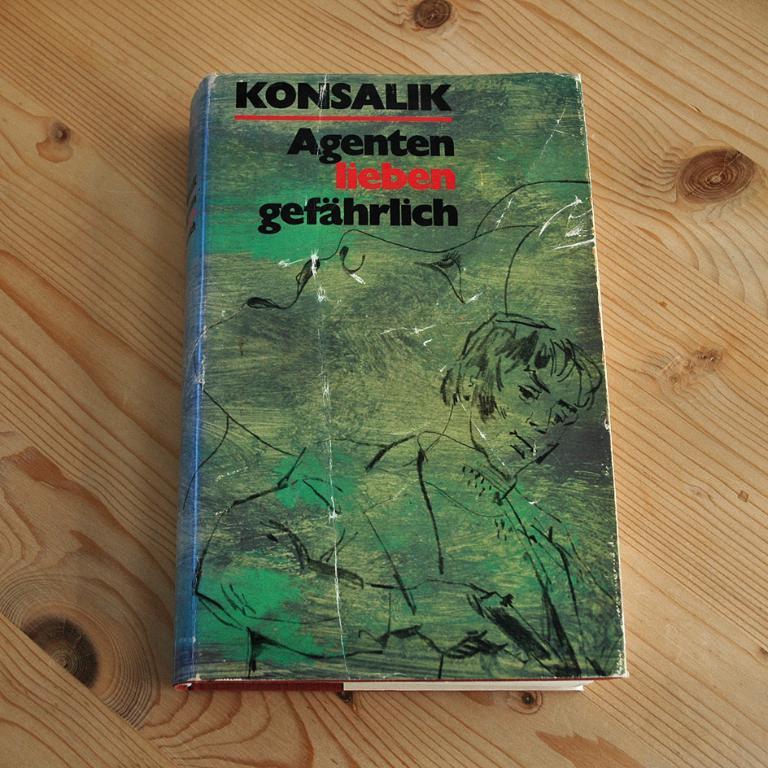Who is the author of this book?
Your answer should be compact. Konsalik. What is the title of this book?
Offer a terse response. Konsalik. 